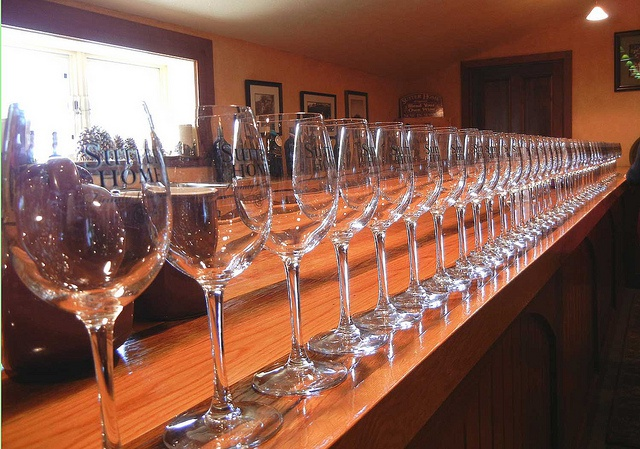Describe the objects in this image and their specific colors. I can see dining table in lightgreen, maroon, red, and brown tones, wine glass in lightgreen, white, gray, maroon, and brown tones, wine glass in lightgreen, brown, maroon, and white tones, wine glass in lightgreen, brown, and maroon tones, and wine glass in lightgreen, brown, gray, darkgray, and lightgray tones in this image. 